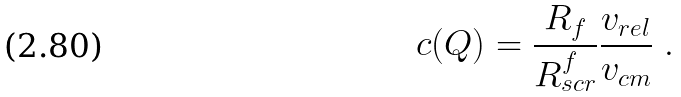<formula> <loc_0><loc_0><loc_500><loc_500>c ( Q ) = \frac { R _ { f } } { R _ { s c r } ^ { f } } \frac { v _ { r e l } } { v _ { c m } } \ .</formula> 